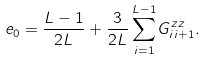<formula> <loc_0><loc_0><loc_500><loc_500>e _ { 0 } = \frac { L - 1 } { 2 L } + \frac { 3 } { 2 L } \sum _ { i = 1 } ^ { L - 1 } G _ { i i + 1 } ^ { z z } .</formula> 